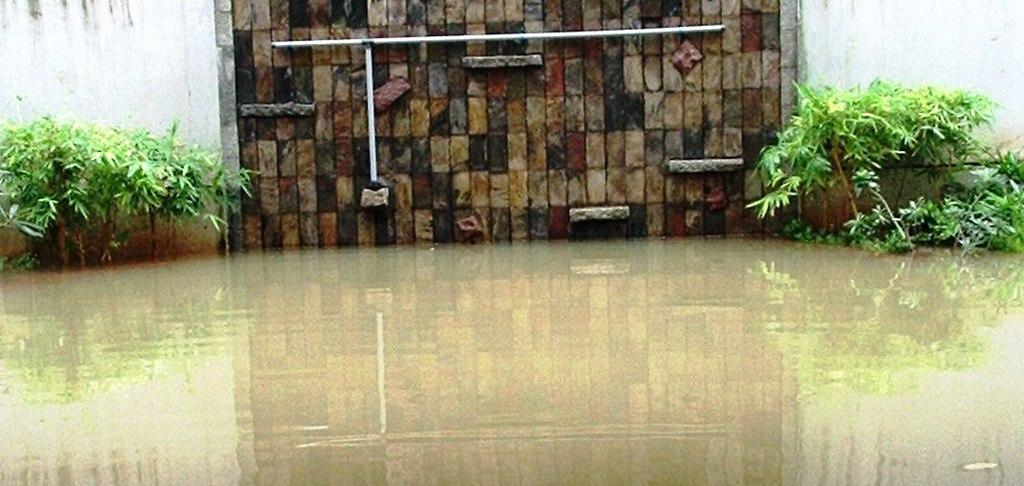What is visible in the image? Water is visible in the image. What can be seen in the background of the image? There are plants, rods, and a wall in the background of the image. What type of popcorn is being served at the war depicted in the image? There is no war or popcorn present in the image; it features water and background elements like plants, rods, and a wall. 